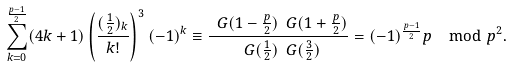Convert formula to latex. <formula><loc_0><loc_0><loc_500><loc_500>\sum _ { k = 0 } ^ { \frac { p - 1 } { 2 } } ( 4 k + 1 ) \left ( \frac { ( \frac { 1 } { 2 } ) _ { k } } { k ! } \right ) ^ { 3 } ( - 1 ) ^ { k } \equiv \frac { \ G ( 1 - \frac { p } { 2 } ) \ G ( 1 + \frac { p } { 2 } ) } { \ G ( \frac { 1 } { 2 } ) \ G ( \frac { 3 } { 2 } ) } = ( - 1 ) ^ { \frac { p - 1 } 2 } p \mod p ^ { 2 } .</formula> 